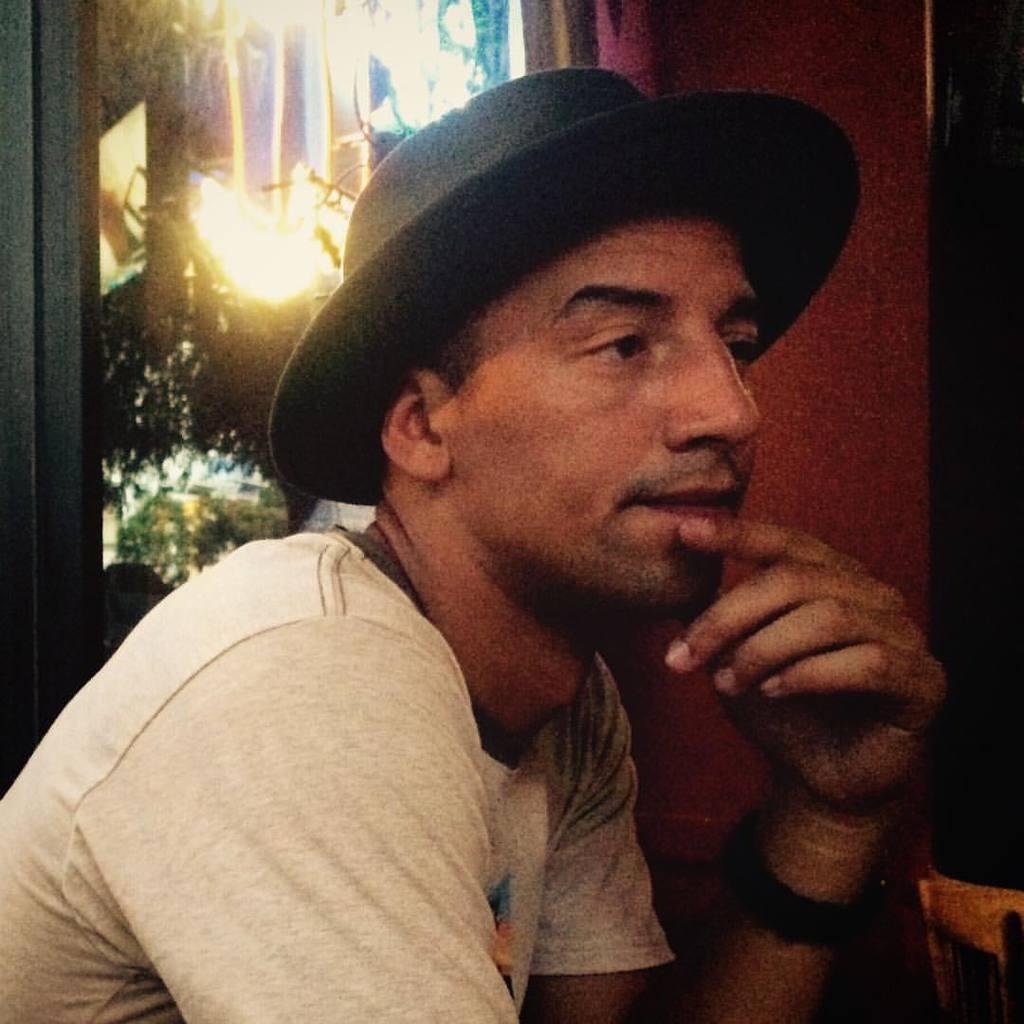Describe this image in one or two sentences. In this image I can see a man is wearing a hat and white color t-shirt. In the background lights and other objects. 